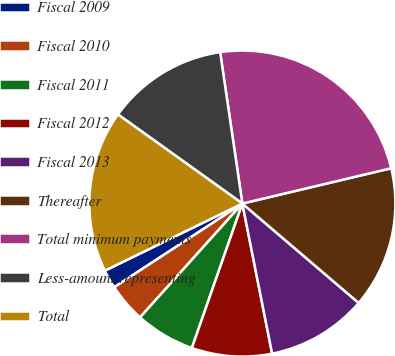<chart> <loc_0><loc_0><loc_500><loc_500><pie_chart><fcel>Fiscal 2009<fcel>Fiscal 2010<fcel>Fiscal 2011<fcel>Fiscal 2012<fcel>Fiscal 2013<fcel>Thereafter<fcel>Total minimum payments<fcel>Less-amount representing<fcel>Total<nl><fcel>1.98%<fcel>4.14%<fcel>6.3%<fcel>8.47%<fcel>10.63%<fcel>14.96%<fcel>23.61%<fcel>12.79%<fcel>17.12%<nl></chart> 